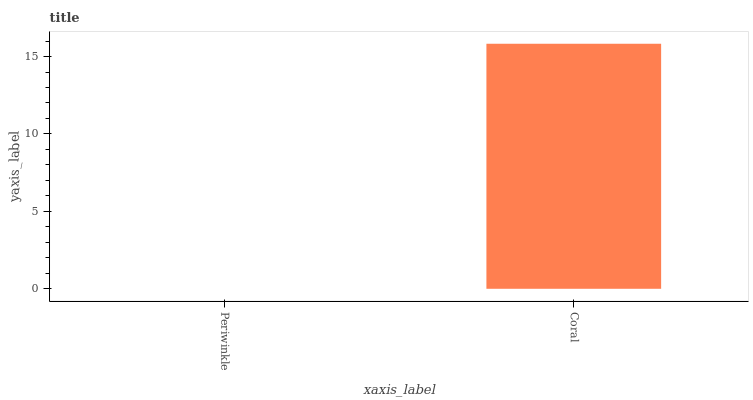Is Periwinkle the minimum?
Answer yes or no. Yes. Is Coral the maximum?
Answer yes or no. Yes. Is Coral the minimum?
Answer yes or no. No. Is Coral greater than Periwinkle?
Answer yes or no. Yes. Is Periwinkle less than Coral?
Answer yes or no. Yes. Is Periwinkle greater than Coral?
Answer yes or no. No. Is Coral less than Periwinkle?
Answer yes or no. No. Is Coral the high median?
Answer yes or no. Yes. Is Periwinkle the low median?
Answer yes or no. Yes. Is Periwinkle the high median?
Answer yes or no. No. Is Coral the low median?
Answer yes or no. No. 